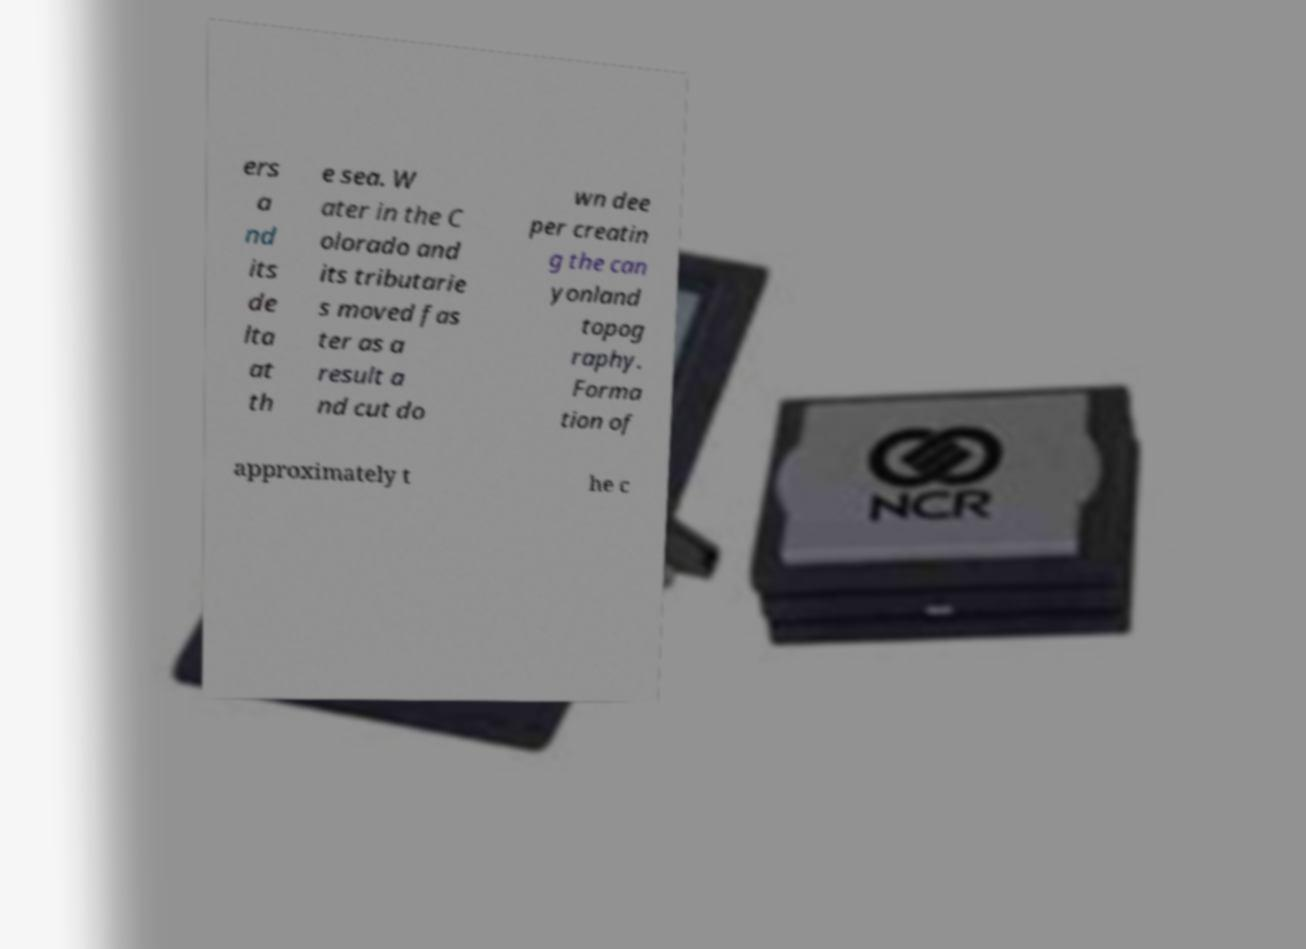Can you read and provide the text displayed in the image?This photo seems to have some interesting text. Can you extract and type it out for me? ers a nd its de lta at th e sea. W ater in the C olorado and its tributarie s moved fas ter as a result a nd cut do wn dee per creatin g the can yonland topog raphy. Forma tion of approximately t he c 